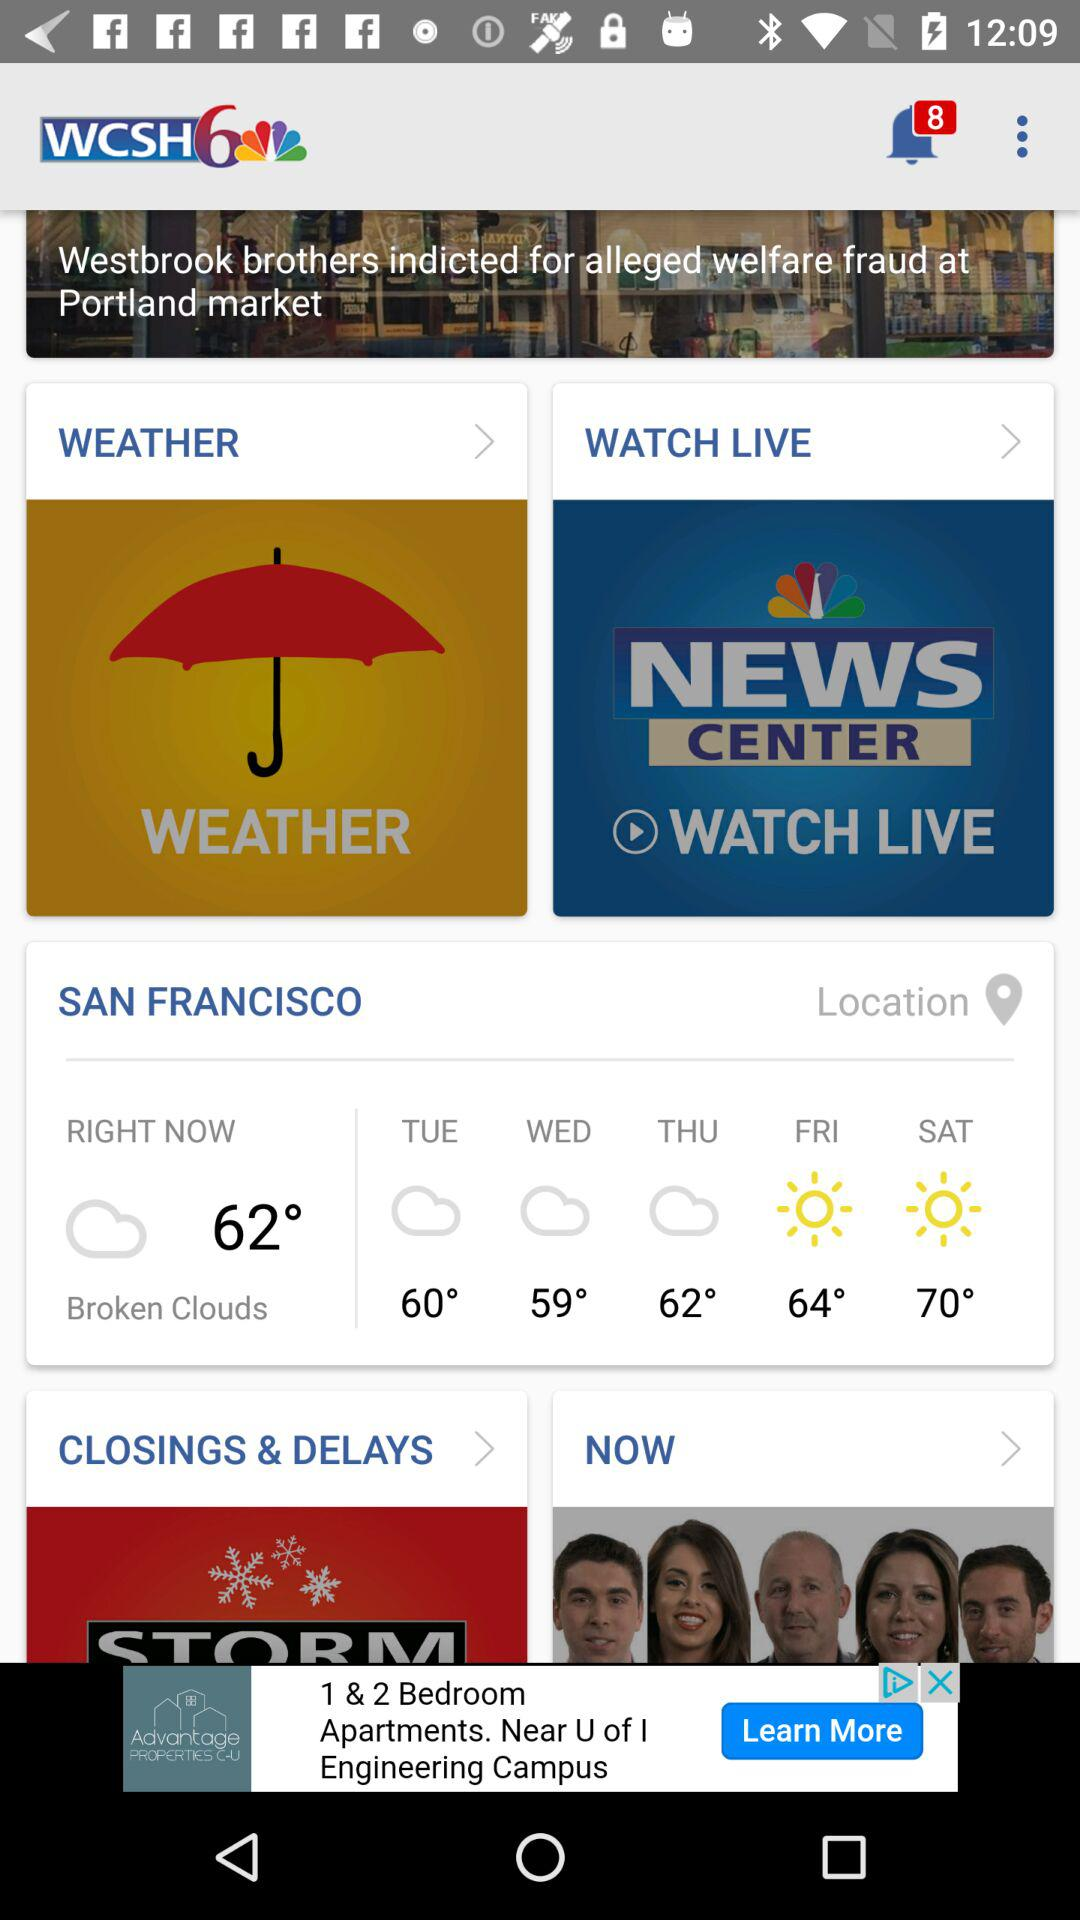What is the shown location? The shown location is San Francisco. 